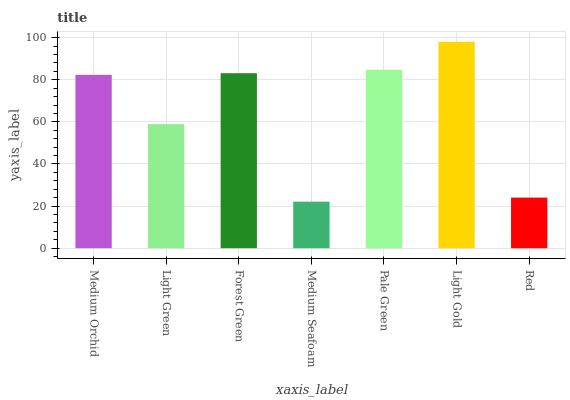Is Light Green the minimum?
Answer yes or no. No. Is Light Green the maximum?
Answer yes or no. No. Is Medium Orchid greater than Light Green?
Answer yes or no. Yes. Is Light Green less than Medium Orchid?
Answer yes or no. Yes. Is Light Green greater than Medium Orchid?
Answer yes or no. No. Is Medium Orchid less than Light Green?
Answer yes or no. No. Is Medium Orchid the high median?
Answer yes or no. Yes. Is Medium Orchid the low median?
Answer yes or no. Yes. Is Light Gold the high median?
Answer yes or no. No. Is Red the low median?
Answer yes or no. No. 